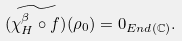<formula> <loc_0><loc_0><loc_500><loc_500>\widetilde { ( \chi ^ { \beta } _ { H } \circ f ) } ( \rho _ { 0 } ) = 0 _ { { E n d } ( { \mathbb { C } } ) } .</formula> 